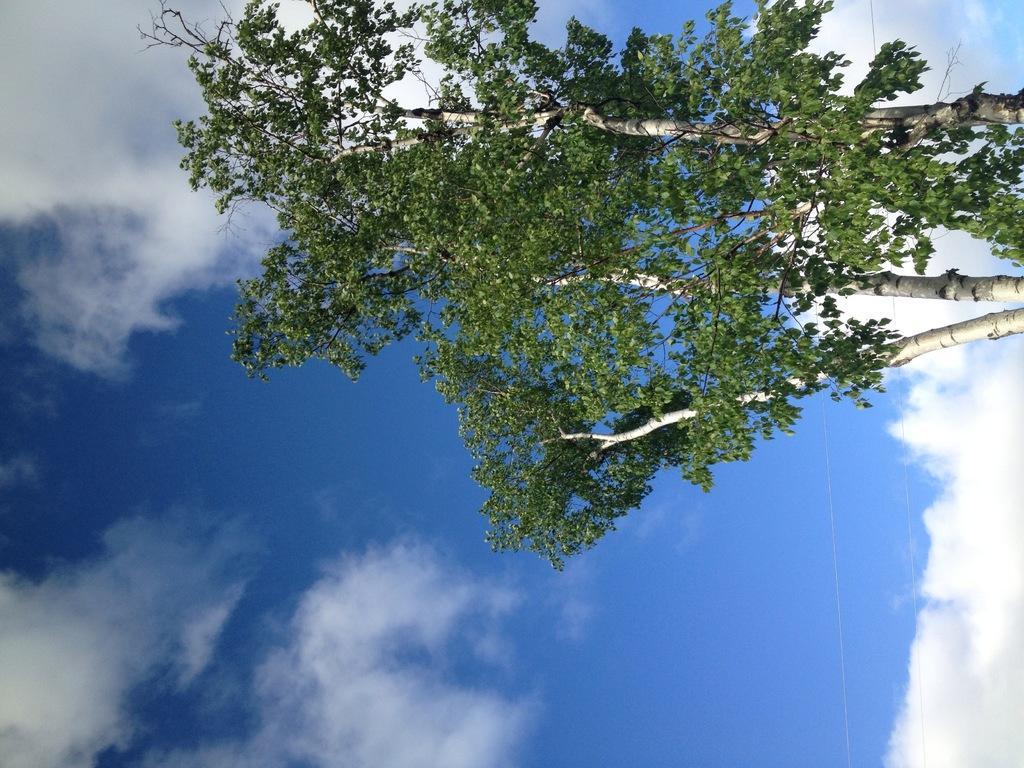How would you summarize this image in a sentence or two? In this image I can see the green color tree and the sky is in blue and white color. 